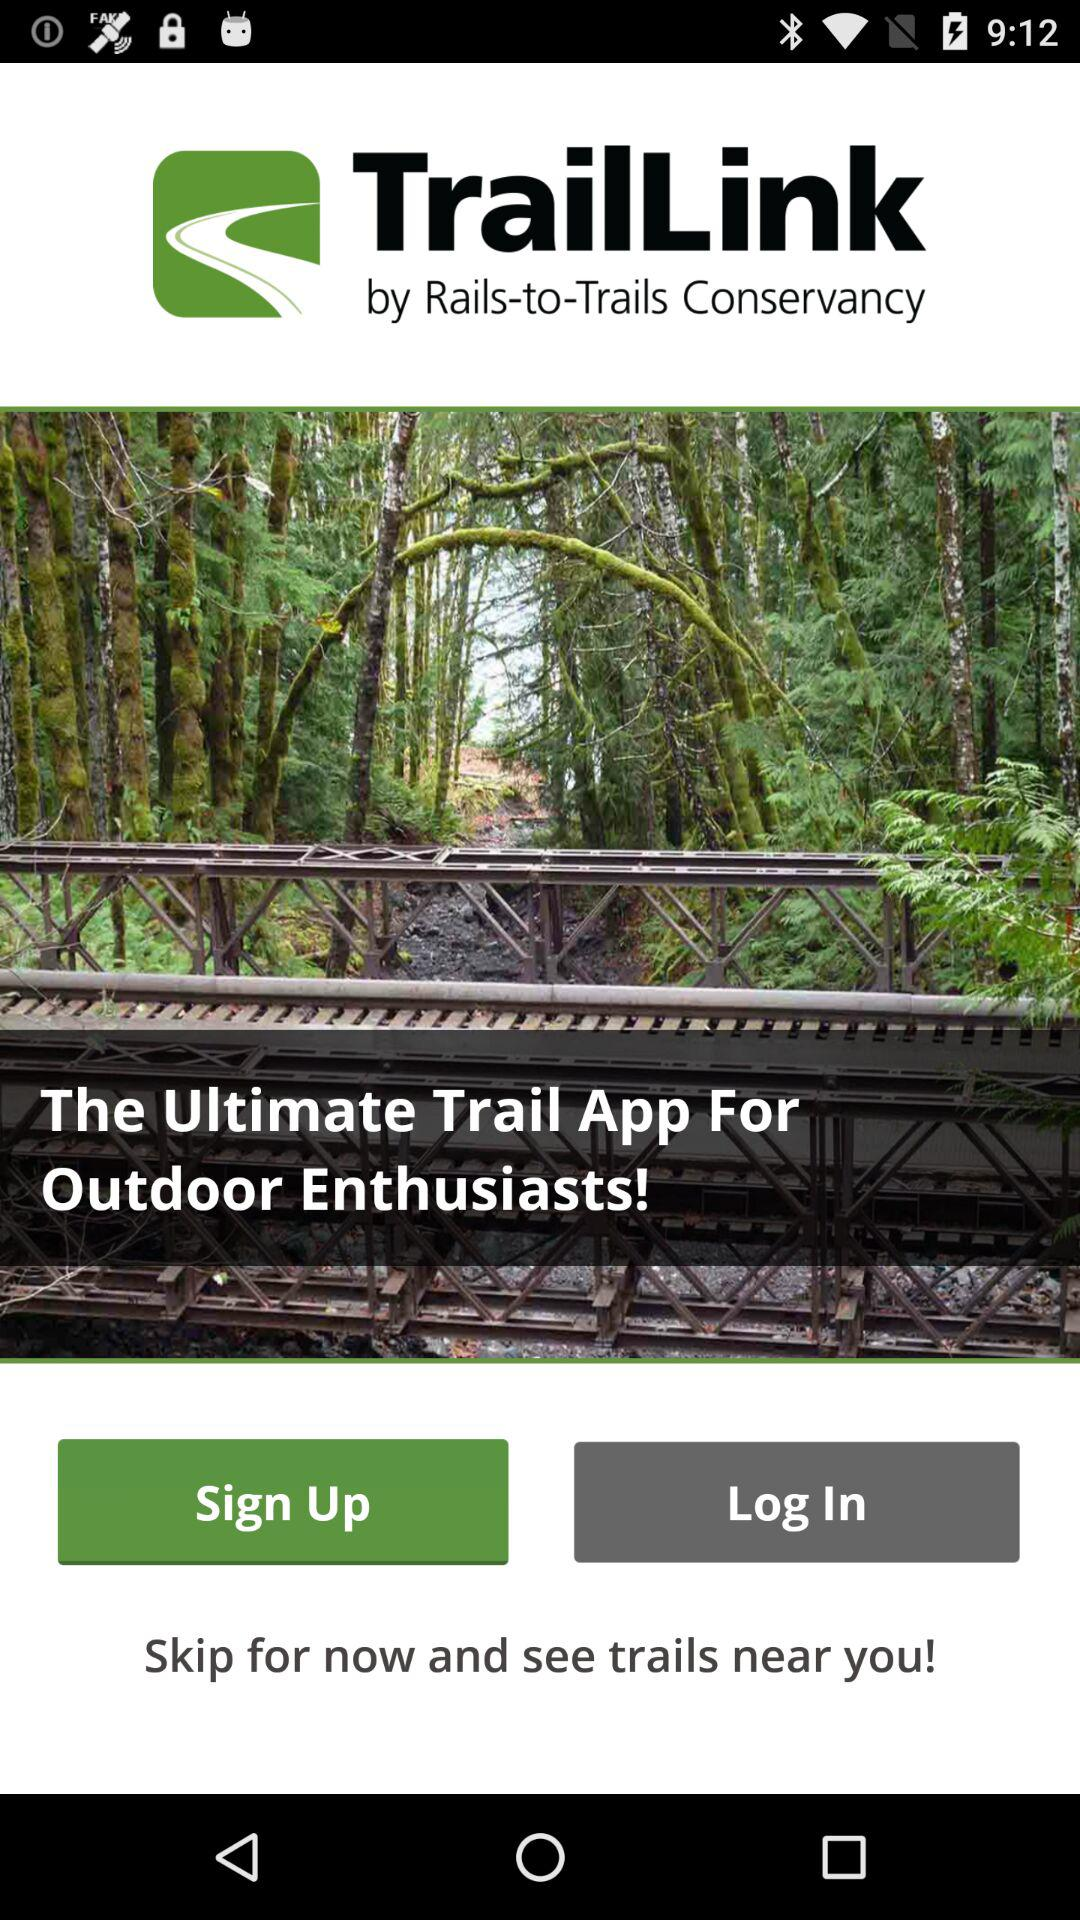What is the purpose of this app?
When the provided information is insufficient, respond with <no answer>. <no answer> 